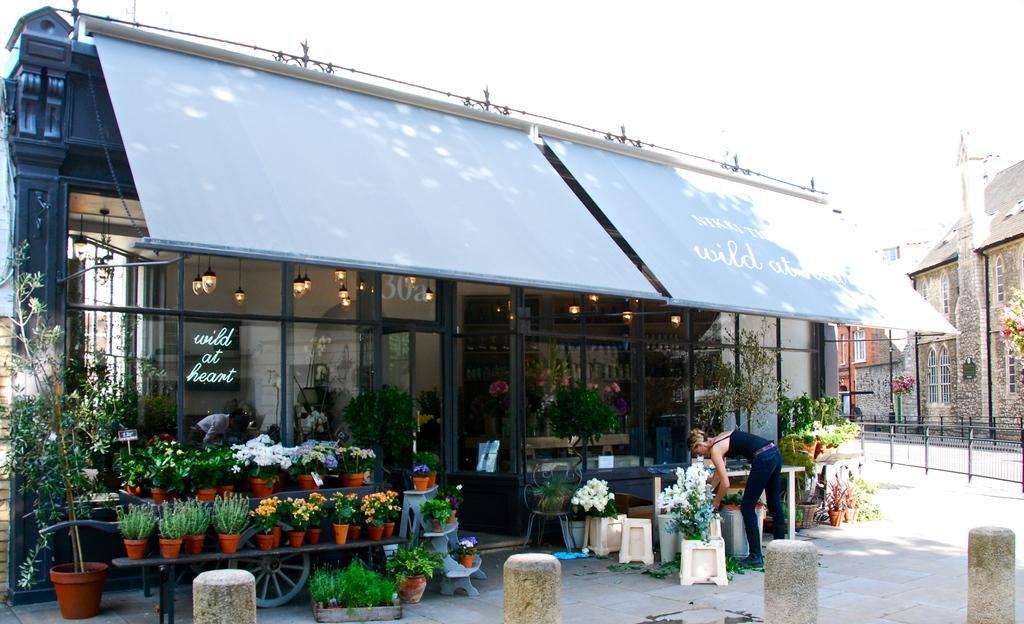Could you give a brief overview of what you see in this image? In this image we can see a store. There are many plants in the store. There are many flowers to the plants. There is some text on the glass in the image. There are few buildings in the image. There is a person in the image. There are many plant pots in the image. 